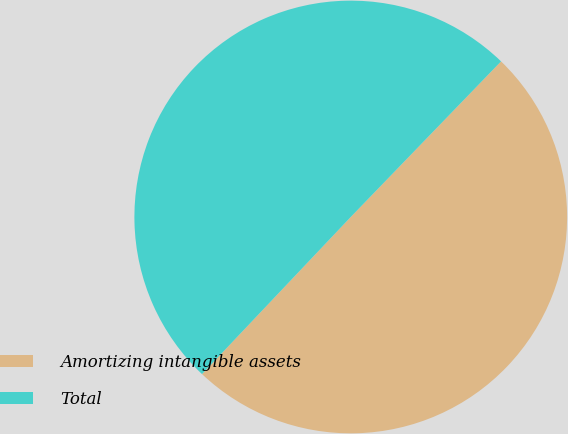Convert chart to OTSL. <chart><loc_0><loc_0><loc_500><loc_500><pie_chart><fcel>Amortizing intangible assets<fcel>Total<nl><fcel>49.84%<fcel>50.16%<nl></chart> 